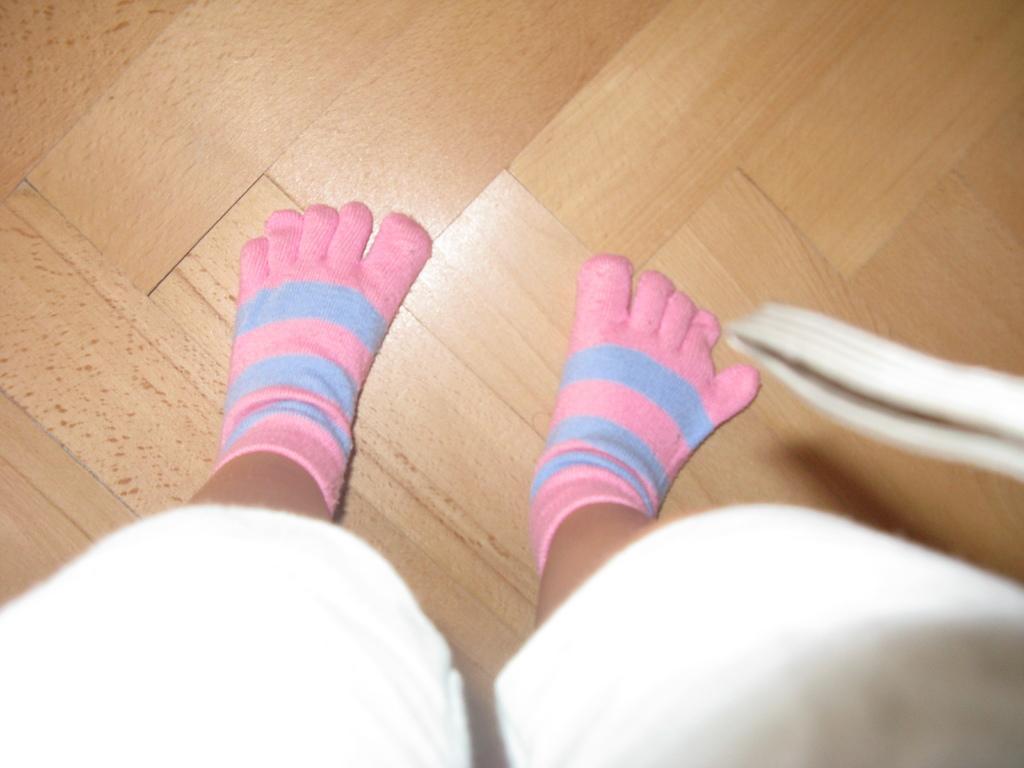Can you describe this image briefly? This picture might be taken inside the room. In this image, we can see a leg of a person which are covered with socks. 